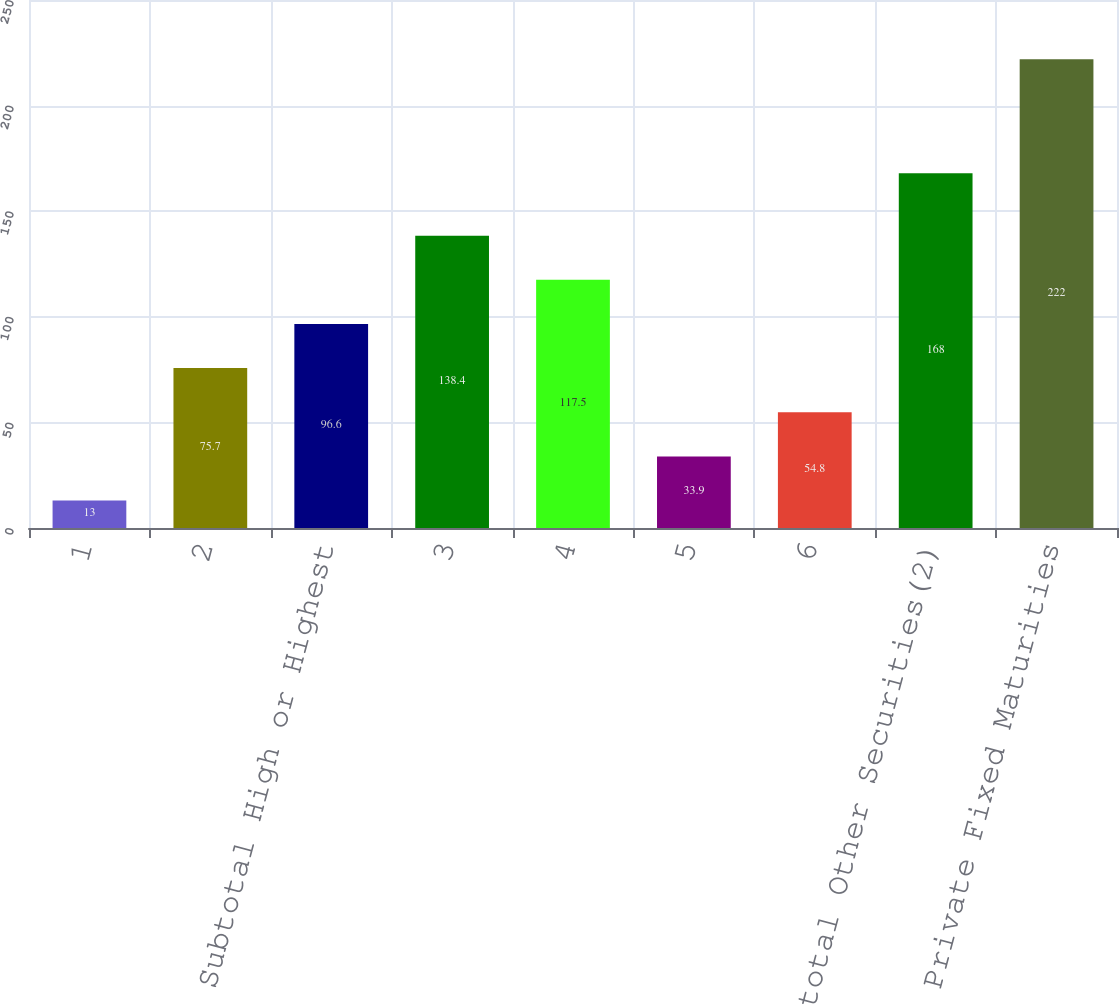<chart> <loc_0><loc_0><loc_500><loc_500><bar_chart><fcel>1<fcel>2<fcel>Subtotal High or Highest<fcel>3<fcel>4<fcel>5<fcel>6<fcel>Subtotal Other Securities(2)<fcel>Total Private Fixed Maturities<nl><fcel>13<fcel>75.7<fcel>96.6<fcel>138.4<fcel>117.5<fcel>33.9<fcel>54.8<fcel>168<fcel>222<nl></chart> 